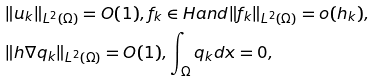Convert formula to latex. <formula><loc_0><loc_0><loc_500><loc_500>& \| u _ { k } \| _ { L ^ { 2 } ( \Omega ) } = O ( 1 ) , f _ { k } \in H a n d \| f _ { k } \| _ { L ^ { 2 } ( \Omega ) } = o ( h _ { k } ) , \\ & \| h \nabla q _ { k } \| _ { L ^ { 2 } ( \Omega ) } = O ( 1 ) , \int _ { \Omega } q _ { k } d x = 0 , \\</formula> 